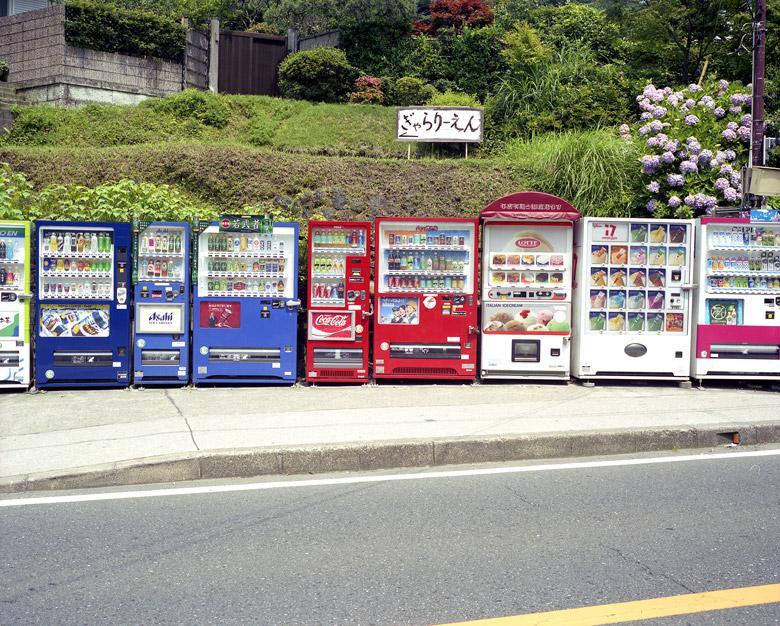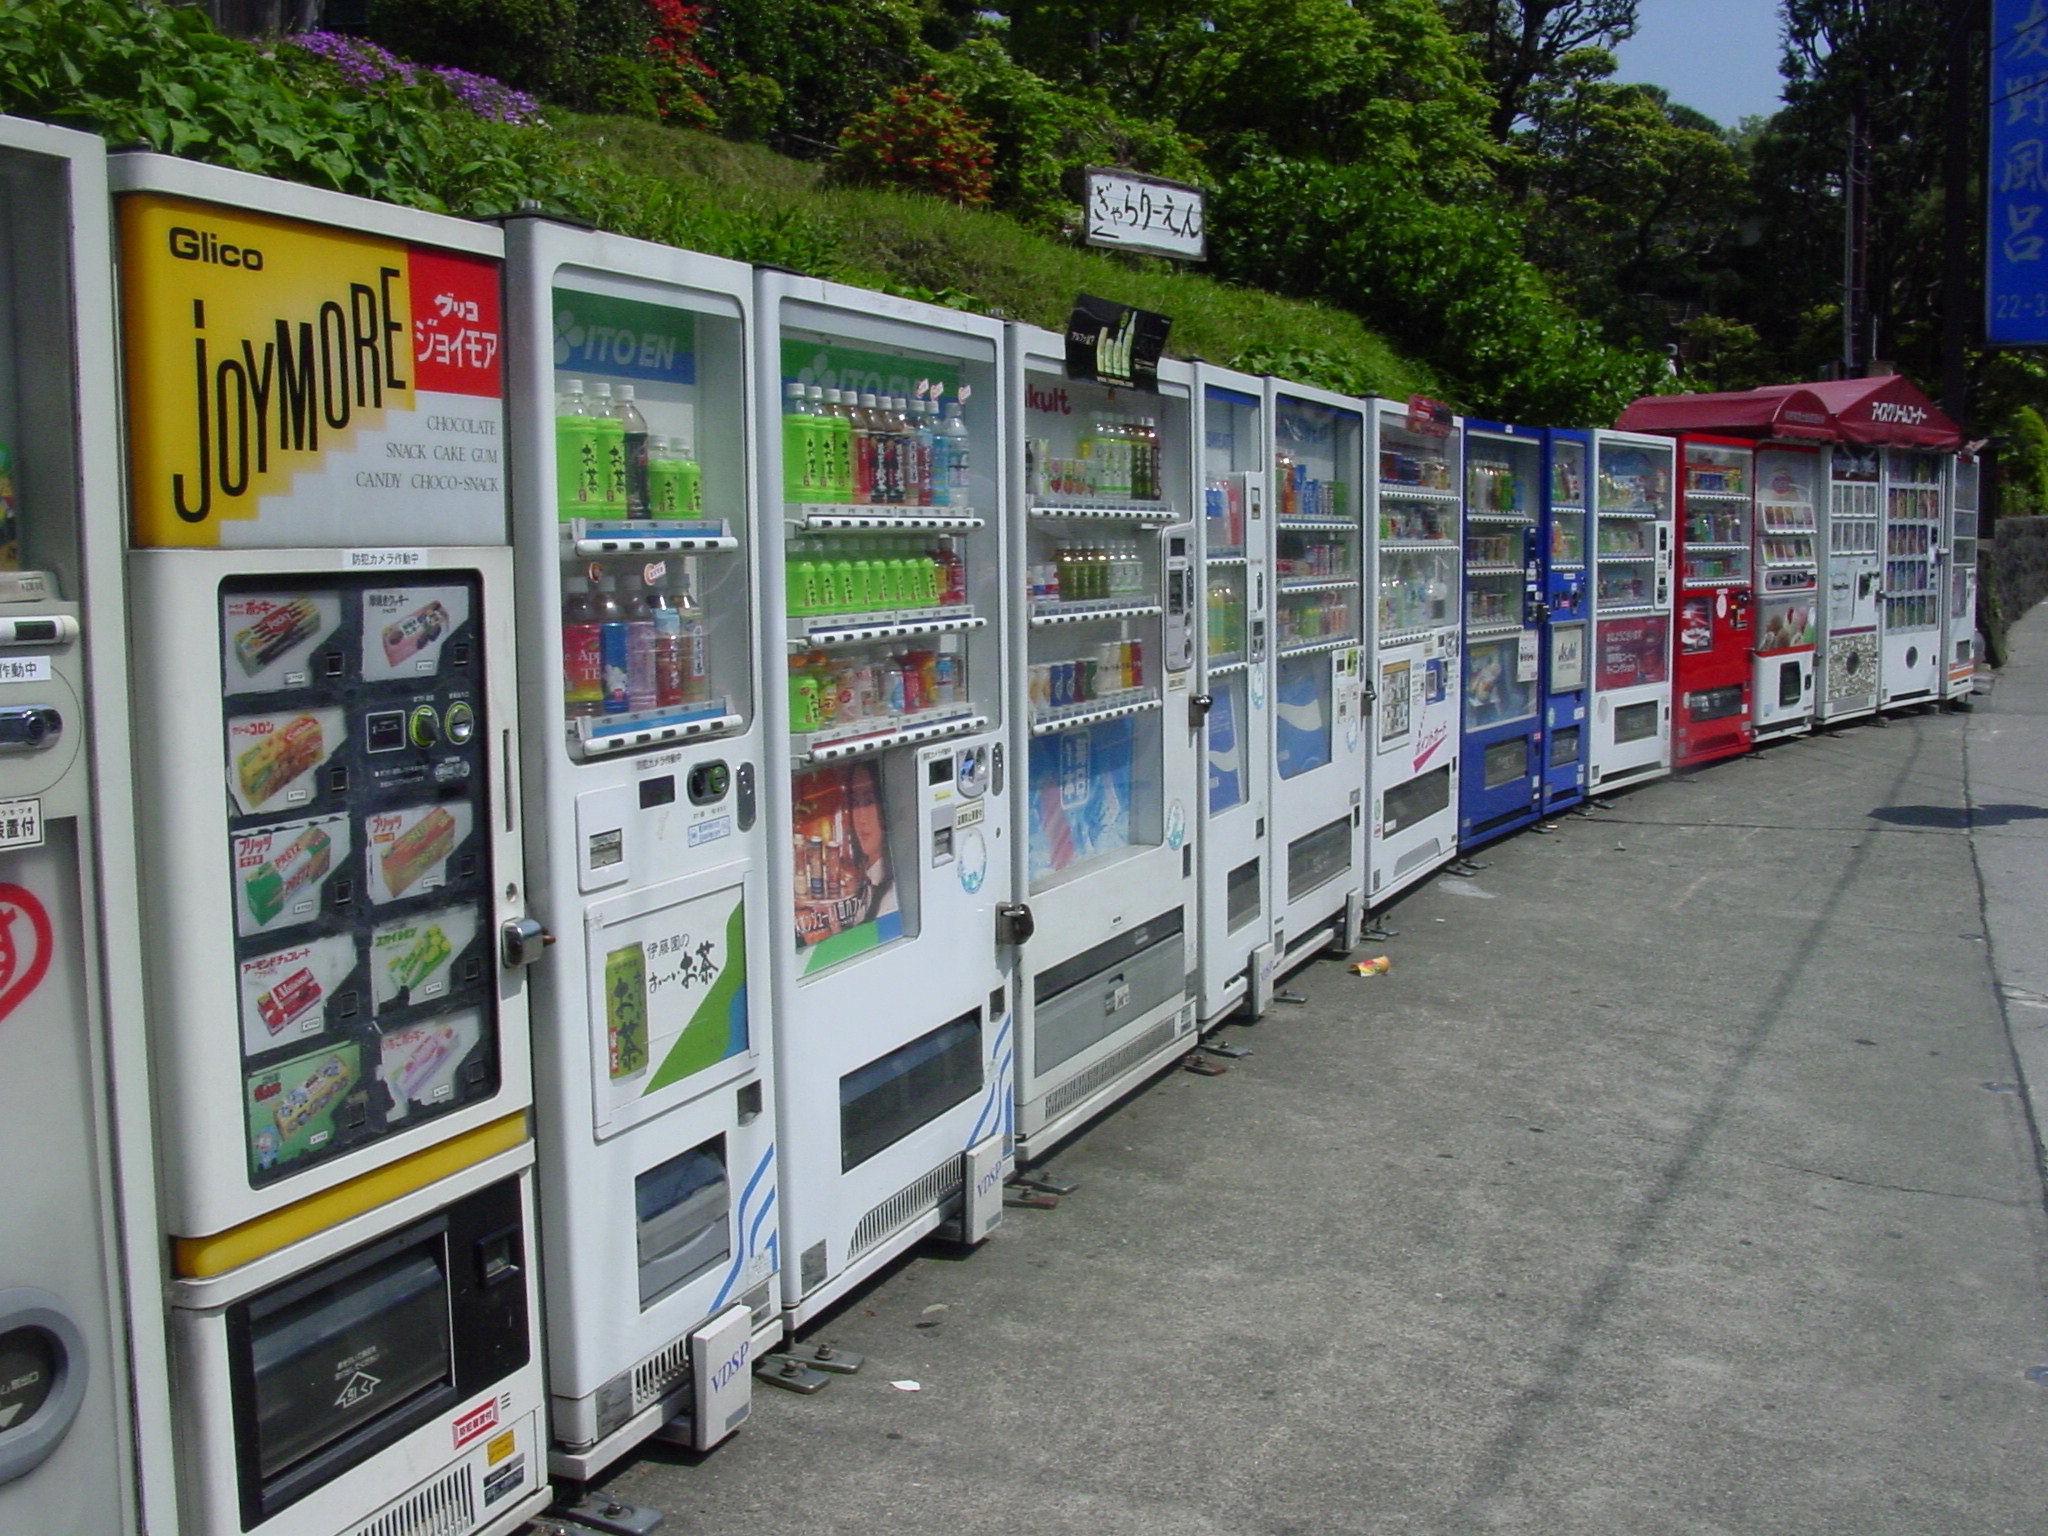The first image is the image on the left, the second image is the image on the right. Analyze the images presented: Is the assertion "There is at least one person standing outside near the machines in the image on the right." valid? Answer yes or no. No. The first image is the image on the left, the second image is the image on the right. Evaluate the accuracy of this statement regarding the images: "A standing person is visible only at the far end of a long row of vending machines.". Is it true? Answer yes or no. No. 